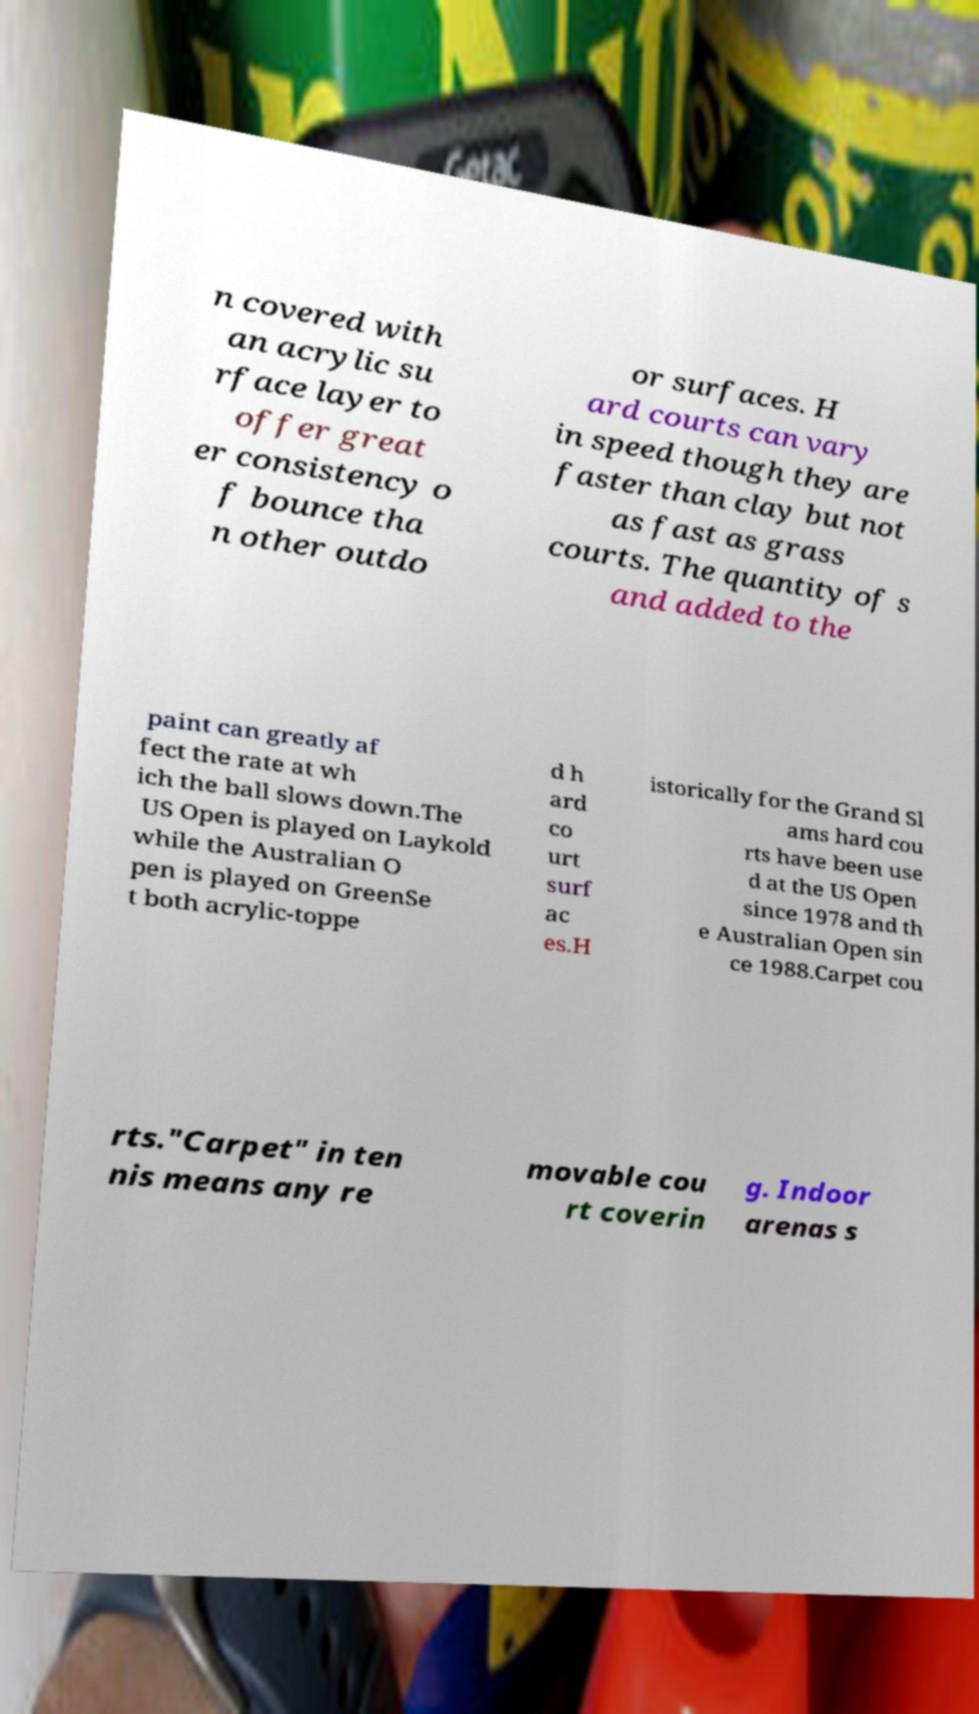Please read and relay the text visible in this image. What does it say? n covered with an acrylic su rface layer to offer great er consistency o f bounce tha n other outdo or surfaces. H ard courts can vary in speed though they are faster than clay but not as fast as grass courts. The quantity of s and added to the paint can greatly af fect the rate at wh ich the ball slows down.The US Open is played on Laykold while the Australian O pen is played on GreenSe t both acrylic-toppe d h ard co urt surf ac es.H istorically for the Grand Sl ams hard cou rts have been use d at the US Open since 1978 and th e Australian Open sin ce 1988.Carpet cou rts."Carpet" in ten nis means any re movable cou rt coverin g. Indoor arenas s 